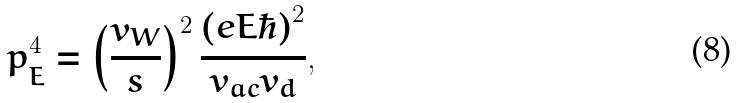<formula> <loc_0><loc_0><loc_500><loc_500>p _ { E } ^ { 4 } = \left ( \frac { v _ { W } } { s } \right ) ^ { 2 } \frac { ( e E \hbar { ) } ^ { 2 } } { v _ { a c } v _ { d } } ,</formula> 